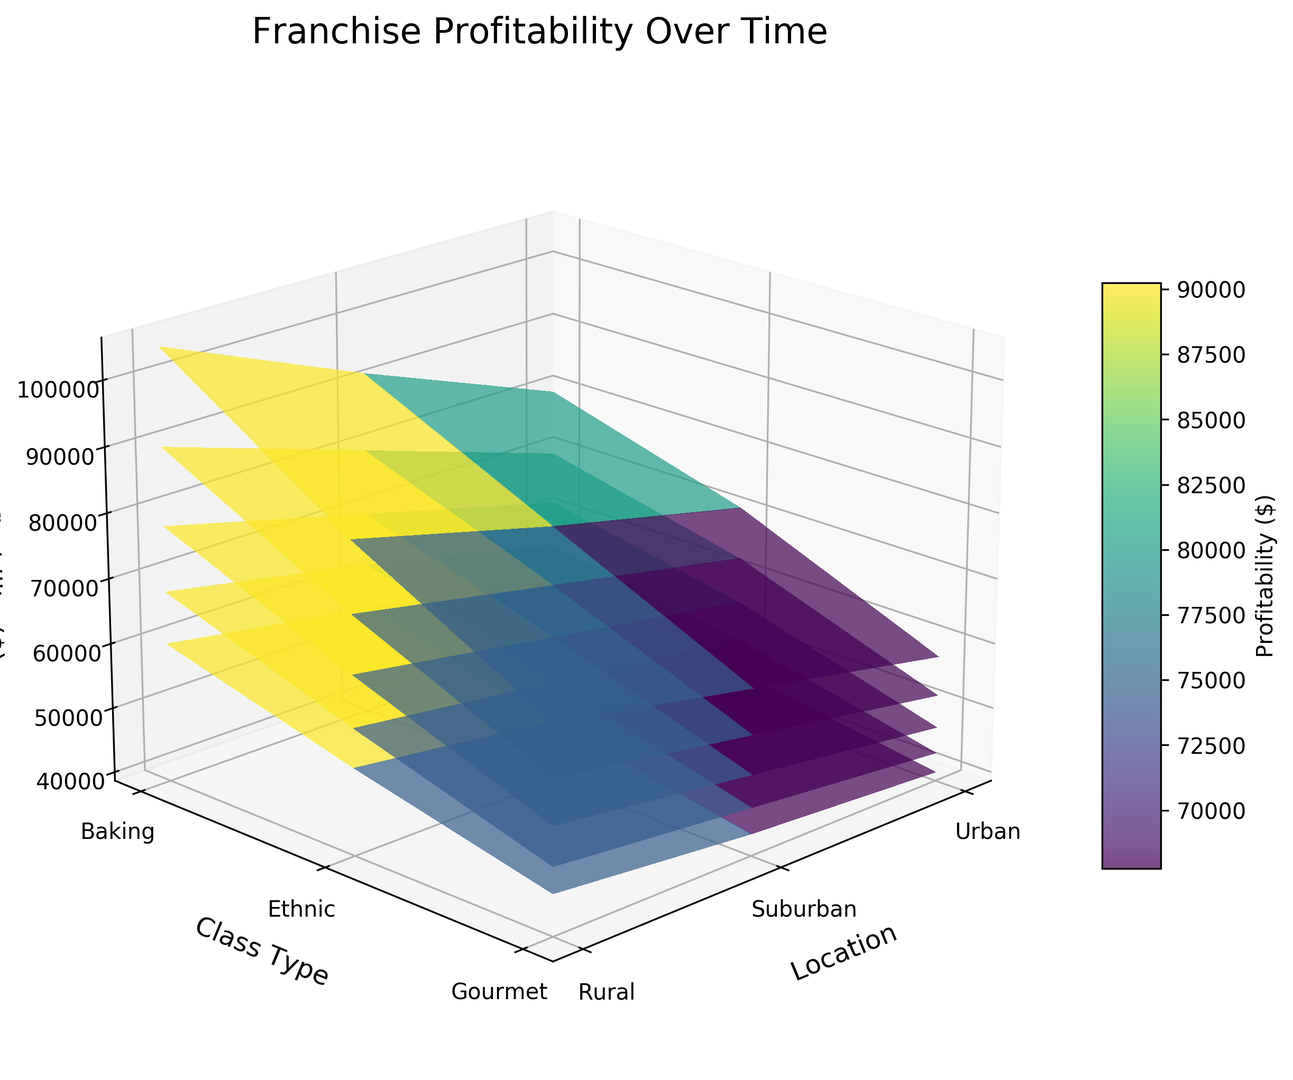Which class type in the Urban location shows the highest profitability in Year 5? First, identify the Urban location on the x-axis. Then look for Year 5 (the last surface plot) and find the highest peak on the z-axis for Urban. The highest peak corresponds to the Gourmet class type.
Answer: Gourmet How has profitability for Suburban Baking classes changed from Year 1 to Year 5? Identify the Baking class type for Suburban on the figure. Observe the z-axis values at Year 1 and Year 5. The profitability rises from 45000 in Year 1 to 71000 in Year 5.
Answer: Increased Which location has the least variance in profitability across all class types by Year 5? Observe the range of heights (z-axis) for each location's class types in Year 5. The Rural location has the most consistent (least variance) profitability levels across its class types.
Answer: Rural Between Ethnic and Gourmet classes in the Suburban location, which one shows a greater increase in profitability from Year 2 to Year 3? Compare the heights of Ethnic and Gourmet classes for Year 2 and Year 3 in Suburban. The Ethnic class increases less (54000 to 61000) compared to the Gourmet class (58000 to 66000).
Answer: Gourmet Calculate the average profitability of all Ethnic classes for Year 4. Sum the profitability values for Ethnic classes across all locations (Urban: 80000, Suburban: 69000, Rural: 57000) in Year 4. Divide by the number of locations. (80000 + 69000 + 57000) / 3 = 206000 / 3 = 68666.67
Answer: 68666.67 What is the difference in profitability between Urban and Rural Baking classes in Year 3? Locate Year 3, then find the z-axis values for Baking classes in Urban (62000) and Rural (47000). Subtract the two values: 62000 - 47000 = 15000
Answer: 15000 Which year shows the largest gap in profitability between Urban and Suburban Gourmet classes? For each year, calculate the difference between Urban and Suburban Gourmet classes. Year 5 has the largest gap: Urban (105000) - Suburban (86000) = 19000
Answer: Year 5 Identify the year with the lowest profitability for Rural Ethnic classes. Check the height of the Rural Ethnic classes across all years on the z-axis. The lowest point occurs in Year 1 with a value of 42000.
Answer: Year 1 Is the profitability trend for Gourmet classes in Urban locations consistently increasing from Year 1 to Year 5? Observe the heights of Urban Gourmet classes for each year from Year 1 to Year 5. The height consistently increases: 60000, 68000, 78000, 90000, 105000.
Answer: Yes 